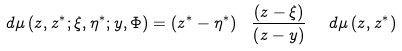Convert formula to latex. <formula><loc_0><loc_0><loc_500><loc_500>d \mu \left ( z , z ^ { \ast } ; \xi , \eta ^ { \ast } ; y , \Phi \right ) = \left ( z ^ { \ast } - \eta ^ { \ast } \right ) \ \frac { \left ( z - \xi \right ) } { \left ( z - y \right ) } \ \ d \mu \left ( z , z ^ { \ast } \right )</formula> 